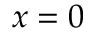<formula> <loc_0><loc_0><loc_500><loc_500>x = 0</formula> 